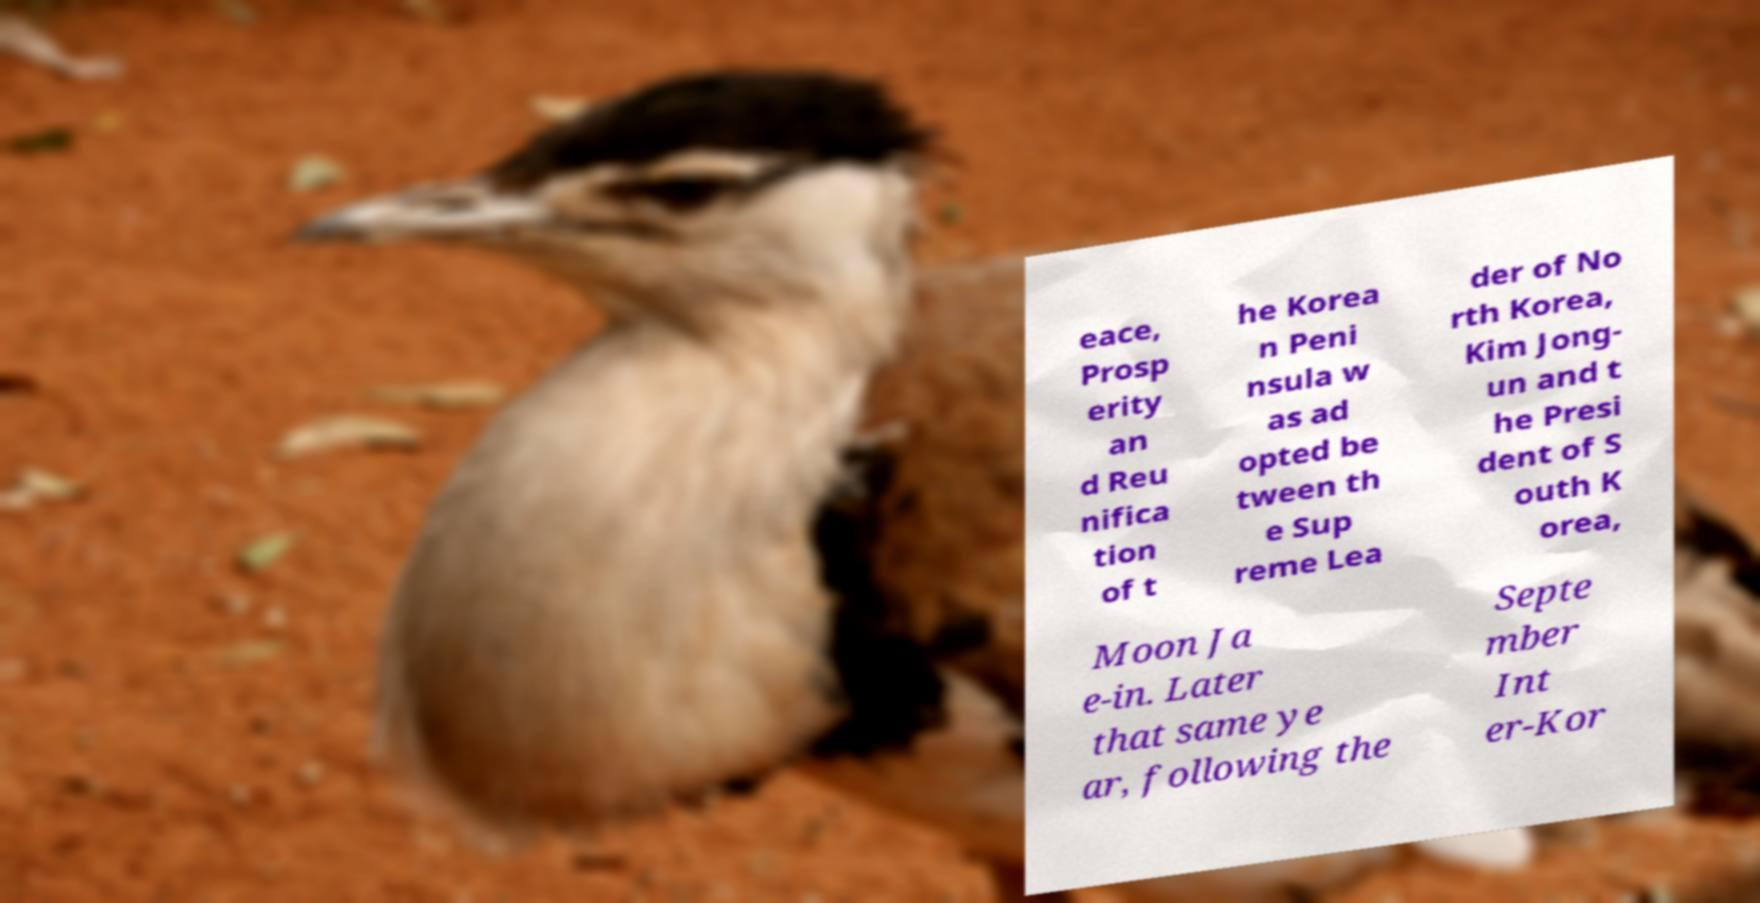Please identify and transcribe the text found in this image. eace, Prosp erity an d Reu nifica tion of t he Korea n Peni nsula w as ad opted be tween th e Sup reme Lea der of No rth Korea, Kim Jong- un and t he Presi dent of S outh K orea, Moon Ja e-in. Later that same ye ar, following the Septe mber Int er-Kor 